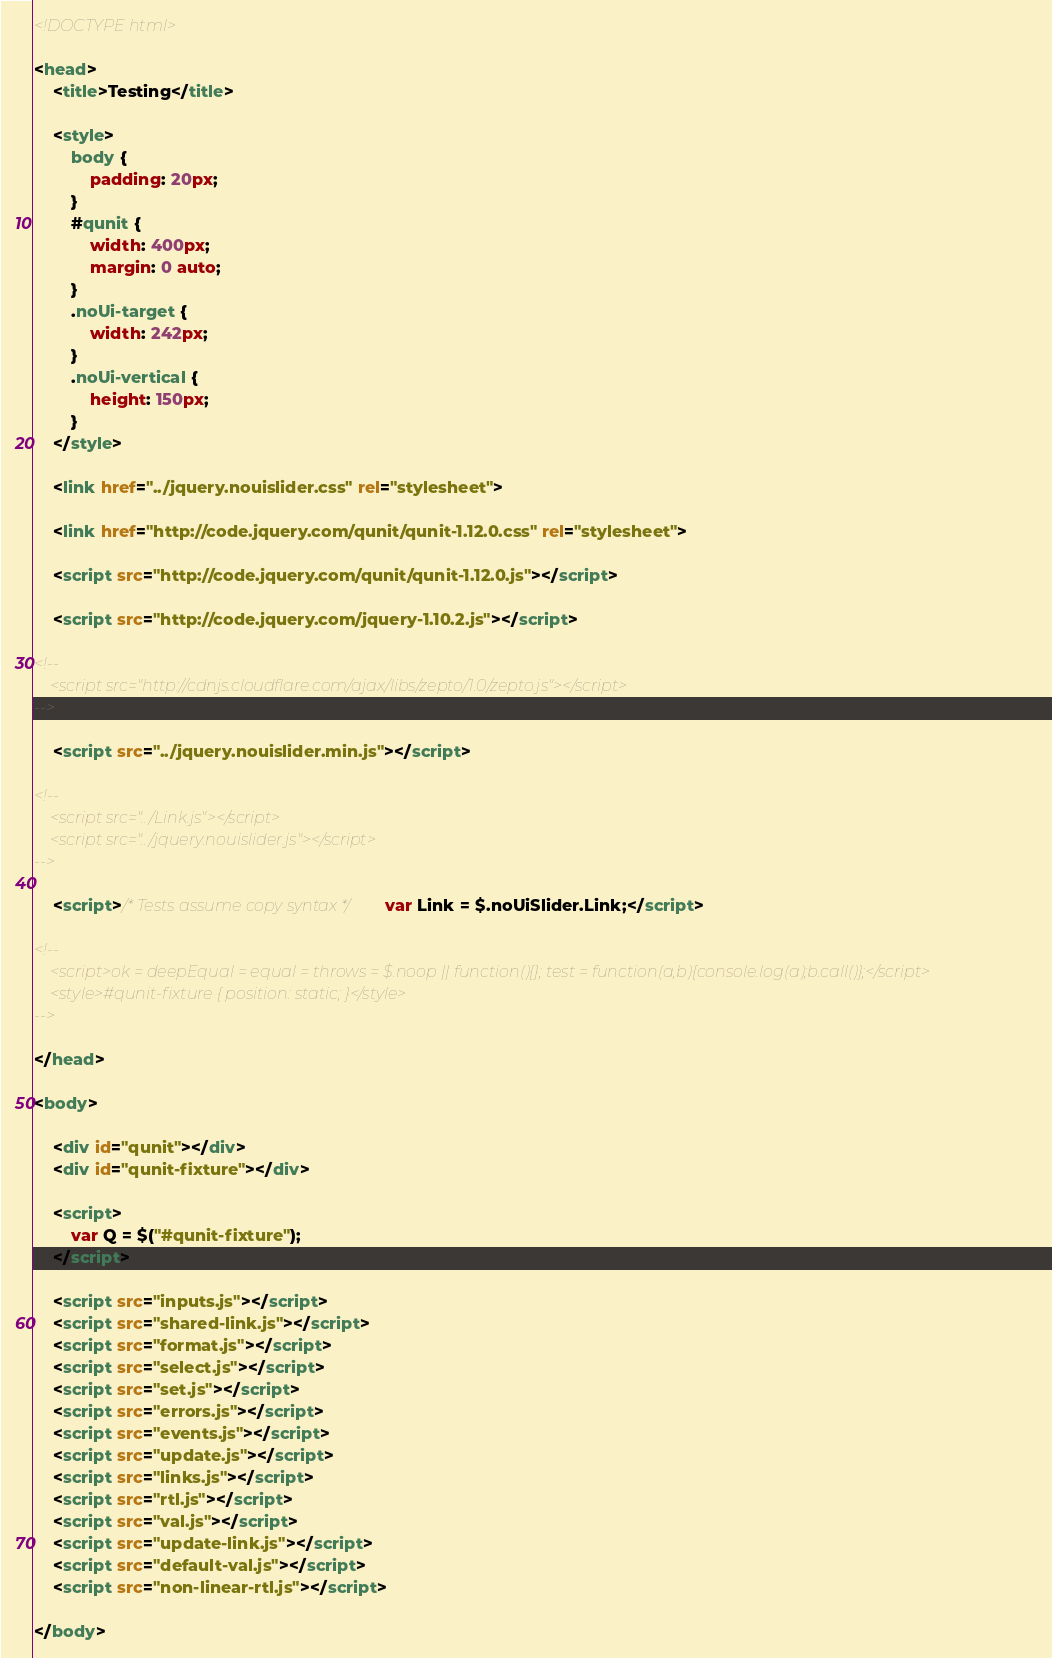Convert code to text. <code><loc_0><loc_0><loc_500><loc_500><_HTML_><!DOCTYPE html>

<head>
	<title>Testing</title>

	<style>
		body {
			padding: 20px;
		}
		#qunit {
			width: 400px;
			margin: 0 auto;
		}
		.noUi-target {
			width: 242px;
		}
		.noUi-vertical {
			height: 150px;
		}
	</style>

	<link href="../jquery.nouislider.css" rel="stylesheet">

	<link href="http://code.jquery.com/qunit/qunit-1.12.0.css" rel="stylesheet">

	<script src="http://code.jquery.com/qunit/qunit-1.12.0.js"></script>

	<script src="http://code.jquery.com/jquery-1.10.2.js"></script>

<!--
	<script src="http://cdnjs.cloudflare.com/ajax/libs/zepto/1.0/zepto.js"></script>
-->

	<script src="../jquery.nouislider.min.js"></script>

<!--
	<script src="../Link.js"></script>
	<script src="../jquery.nouislider.js"></script>
-->

	<script>/* Tests assume copy syntax */ var Link = $.noUiSlider.Link;</script>

<!--
	<script>ok = deepEqual = equal = throws = $.noop || function(){}; test = function(a,b){console.log(a);b.call()};</script>
	<style>#qunit-fixture { position: static; }</style>
-->

</head>

<body>

	<div id="qunit"></div>
	<div id="qunit-fixture"></div>

	<script>
		var Q = $("#qunit-fixture");
	</script>

	<script src="inputs.js"></script>
	<script src="shared-link.js"></script>
	<script src="format.js"></script>
	<script src="select.js"></script>
	<script src="set.js"></script>
	<script src="errors.js"></script>
	<script src="events.js"></script>
	<script src="update.js"></script>
	<script src="links.js"></script>
	<script src="rtl.js"></script>
	<script src="val.js"></script>
	<script src="update-link.js"></script>
	<script src="default-val.js"></script>
	<script src="non-linear-rtl.js"></script>

</body>
</code> 